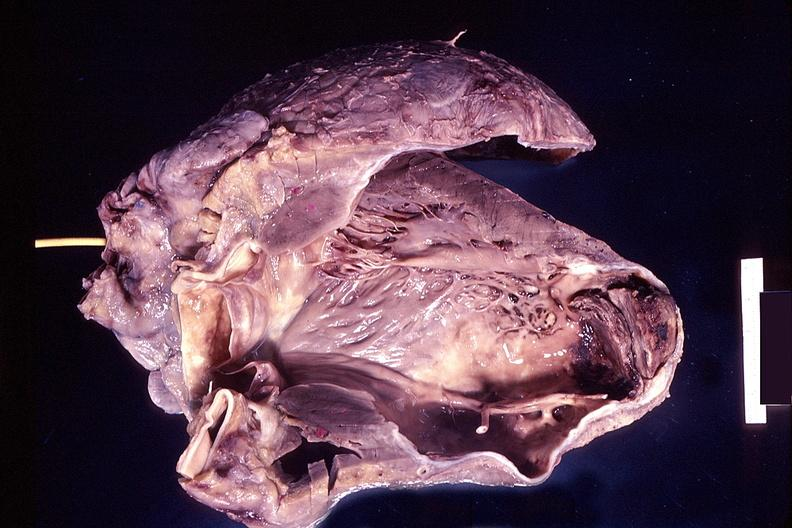what is present?
Answer the question using a single word or phrase. Cardiovascular 